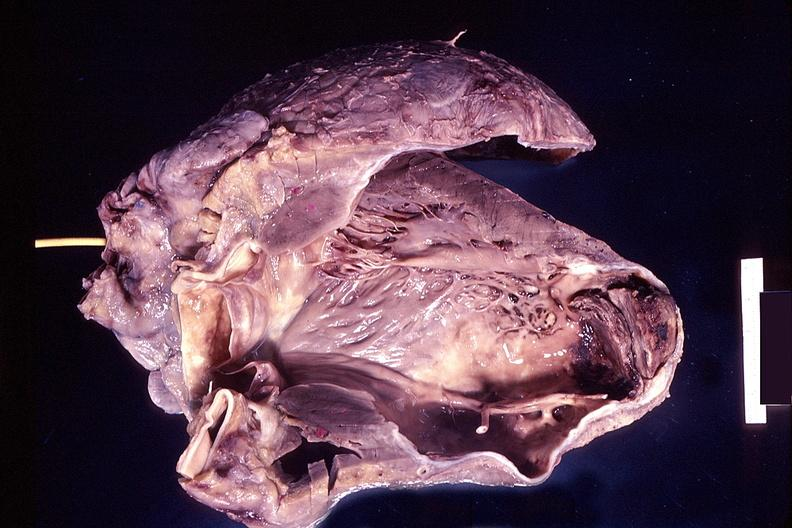what is present?
Answer the question using a single word or phrase. Cardiovascular 